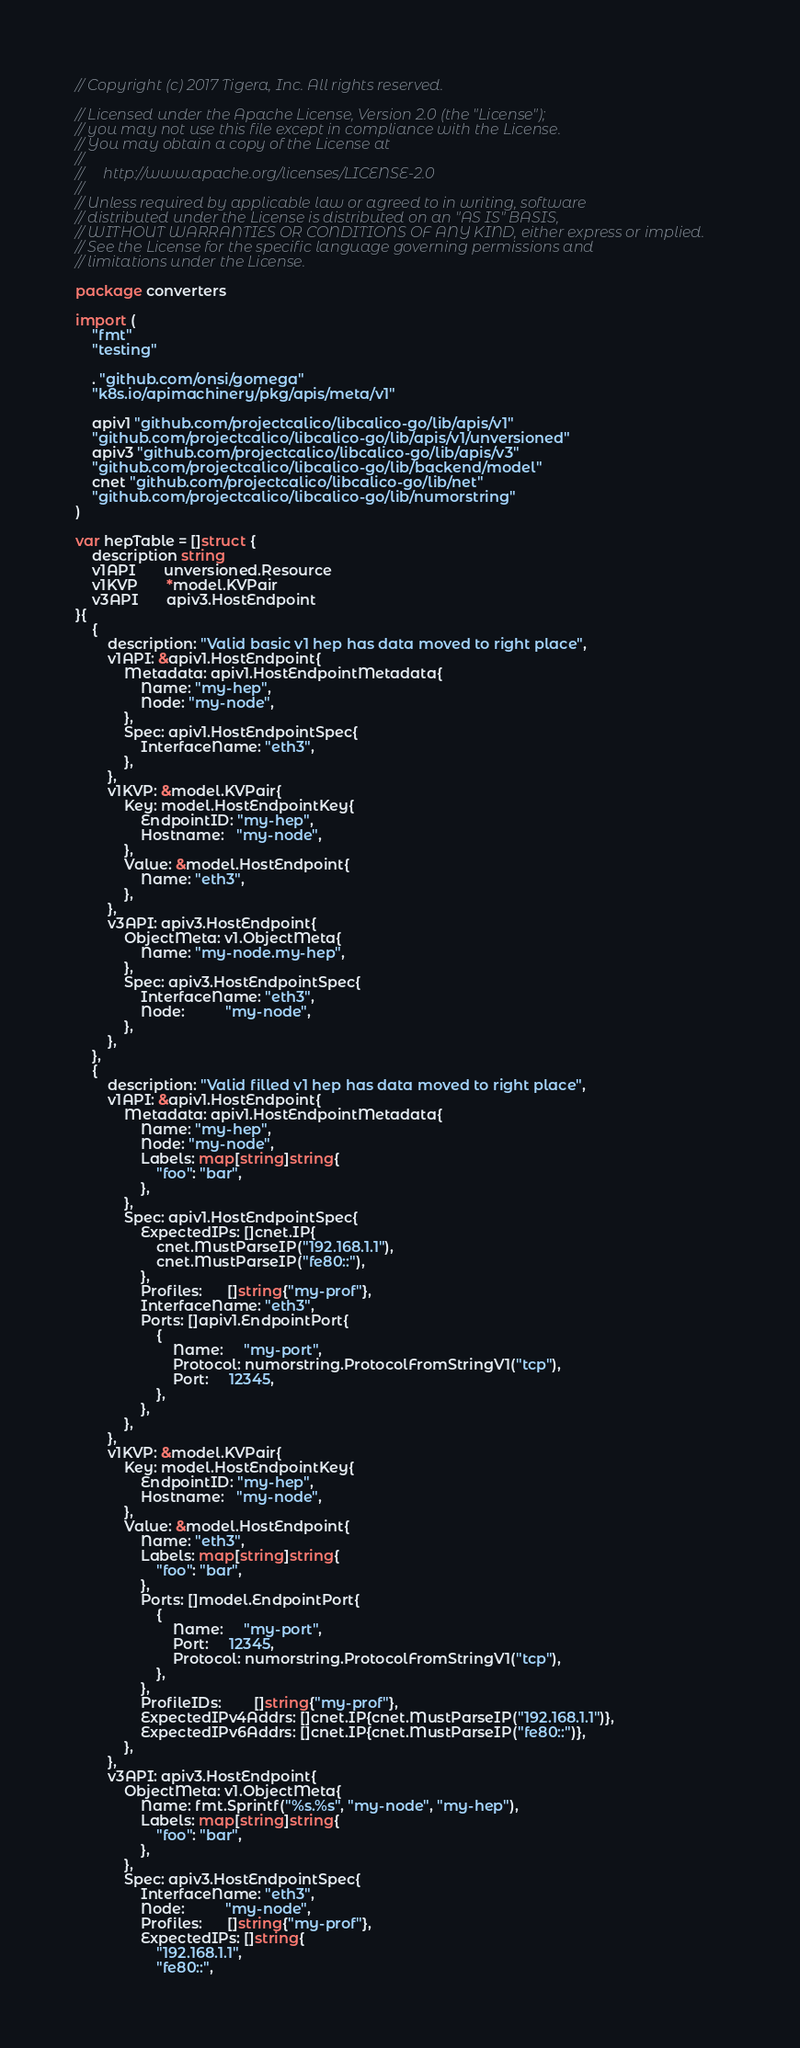Convert code to text. <code><loc_0><loc_0><loc_500><loc_500><_Go_>// Copyright (c) 2017 Tigera, Inc. All rights reserved.

// Licensed under the Apache License, Version 2.0 (the "License");
// you may not use this file except in compliance with the License.
// You may obtain a copy of the License at
//
//     http://www.apache.org/licenses/LICENSE-2.0
//
// Unless required by applicable law or agreed to in writing, software
// distributed under the License is distributed on an "AS IS" BASIS,
// WITHOUT WARRANTIES OR CONDITIONS OF ANY KIND, either express or implied.
// See the License for the specific language governing permissions and
// limitations under the License.

package converters

import (
	"fmt"
	"testing"

	. "github.com/onsi/gomega"
	"k8s.io/apimachinery/pkg/apis/meta/v1"

	apiv1 "github.com/projectcalico/libcalico-go/lib/apis/v1"
	"github.com/projectcalico/libcalico-go/lib/apis/v1/unversioned"
	apiv3 "github.com/projectcalico/libcalico-go/lib/apis/v3"
	"github.com/projectcalico/libcalico-go/lib/backend/model"
	cnet "github.com/projectcalico/libcalico-go/lib/net"
	"github.com/projectcalico/libcalico-go/lib/numorstring"
)

var hepTable = []struct {
	description string
	v1API       unversioned.Resource
	v1KVP       *model.KVPair
	v3API       apiv3.HostEndpoint
}{
	{
		description: "Valid basic v1 hep has data moved to right place",
		v1API: &apiv1.HostEndpoint{
			Metadata: apiv1.HostEndpointMetadata{
				Name: "my-hep",
				Node: "my-node",
			},
			Spec: apiv1.HostEndpointSpec{
				InterfaceName: "eth3",
			},
		},
		v1KVP: &model.KVPair{
			Key: model.HostEndpointKey{
				EndpointID: "my-hep",
				Hostname:   "my-node",
			},
			Value: &model.HostEndpoint{
				Name: "eth3",
			},
		},
		v3API: apiv3.HostEndpoint{
			ObjectMeta: v1.ObjectMeta{
				Name: "my-node.my-hep",
			},
			Spec: apiv3.HostEndpointSpec{
				InterfaceName: "eth3",
				Node:          "my-node",
			},
		},
	},
	{
		description: "Valid filled v1 hep has data moved to right place",
		v1API: &apiv1.HostEndpoint{
			Metadata: apiv1.HostEndpointMetadata{
				Name: "my-hep",
				Node: "my-node",
				Labels: map[string]string{
					"foo": "bar",
				},
			},
			Spec: apiv1.HostEndpointSpec{
				ExpectedIPs: []cnet.IP{
					cnet.MustParseIP("192.168.1.1"),
					cnet.MustParseIP("fe80::"),
				},
				Profiles:      []string{"my-prof"},
				InterfaceName: "eth3",
				Ports: []apiv1.EndpointPort{
					{
						Name:     "my-port",
						Protocol: numorstring.ProtocolFromStringV1("tcp"),
						Port:     12345,
					},
				},
			},
		},
		v1KVP: &model.KVPair{
			Key: model.HostEndpointKey{
				EndpointID: "my-hep",
				Hostname:   "my-node",
			},
			Value: &model.HostEndpoint{
				Name: "eth3",
				Labels: map[string]string{
					"foo": "bar",
				},
				Ports: []model.EndpointPort{
					{
						Name:     "my-port",
						Port:     12345,
						Protocol: numorstring.ProtocolFromStringV1("tcp"),
					},
				},
				ProfileIDs:        []string{"my-prof"},
				ExpectedIPv4Addrs: []cnet.IP{cnet.MustParseIP("192.168.1.1")},
				ExpectedIPv6Addrs: []cnet.IP{cnet.MustParseIP("fe80::")},
			},
		},
		v3API: apiv3.HostEndpoint{
			ObjectMeta: v1.ObjectMeta{
				Name: fmt.Sprintf("%s.%s", "my-node", "my-hep"),
				Labels: map[string]string{
					"foo": "bar",
				},
			},
			Spec: apiv3.HostEndpointSpec{
				InterfaceName: "eth3",
				Node:          "my-node",
				Profiles:      []string{"my-prof"},
				ExpectedIPs: []string{
					"192.168.1.1",
					"fe80::",</code> 